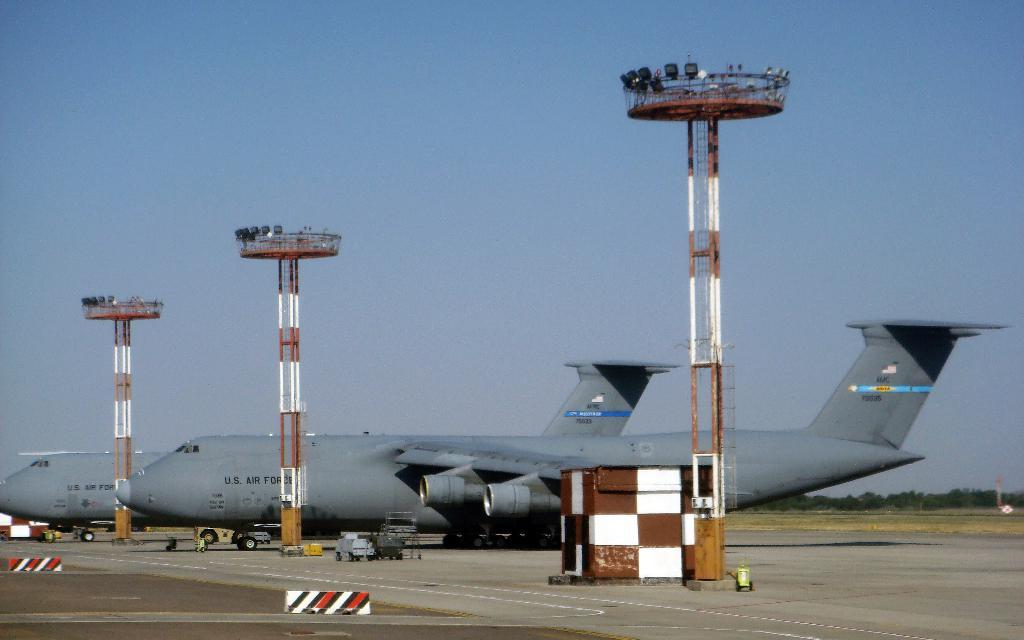What structures are present in the image? There are poles in the image. What type of transportation is visible on the ground? There are airplanes on the ground in the image. What else can be seen in the image besides poles and airplanes? There are vehicles in the image. What can be seen in the distance in the image? There are trees in the background of the image. Where is the crow sitting in the image? There is no crow present in the image. What type of glue is being used to hold the cave together in the image? There is no cave or glue present in the image. 